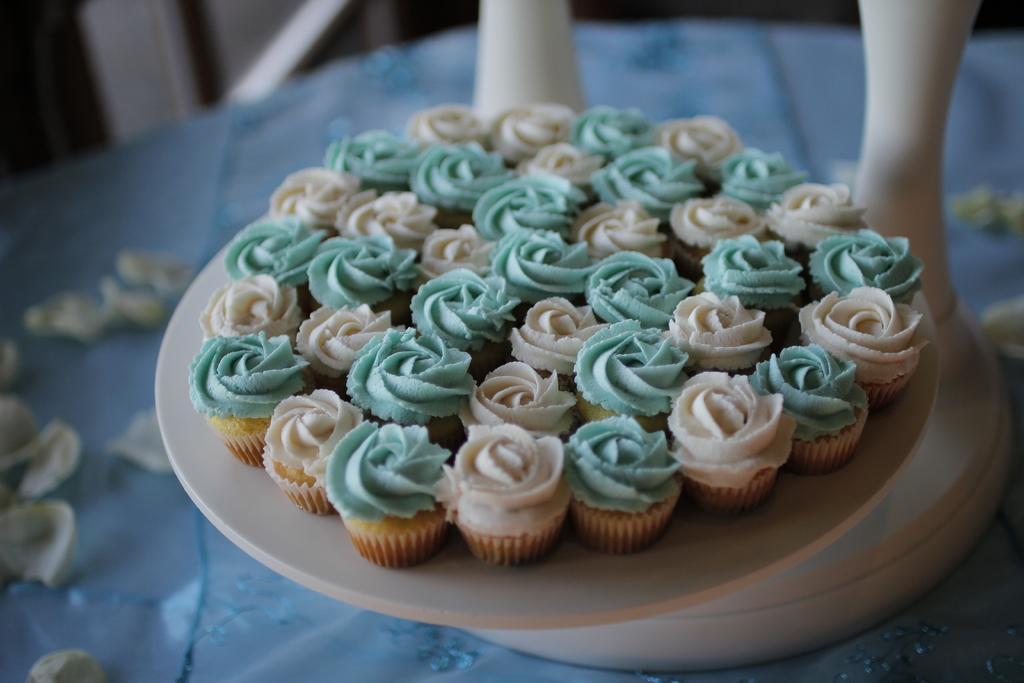Could you give a brief overview of what you see in this image? In this picture we can see cupcakes on a plate and in the background we can see some objects. 